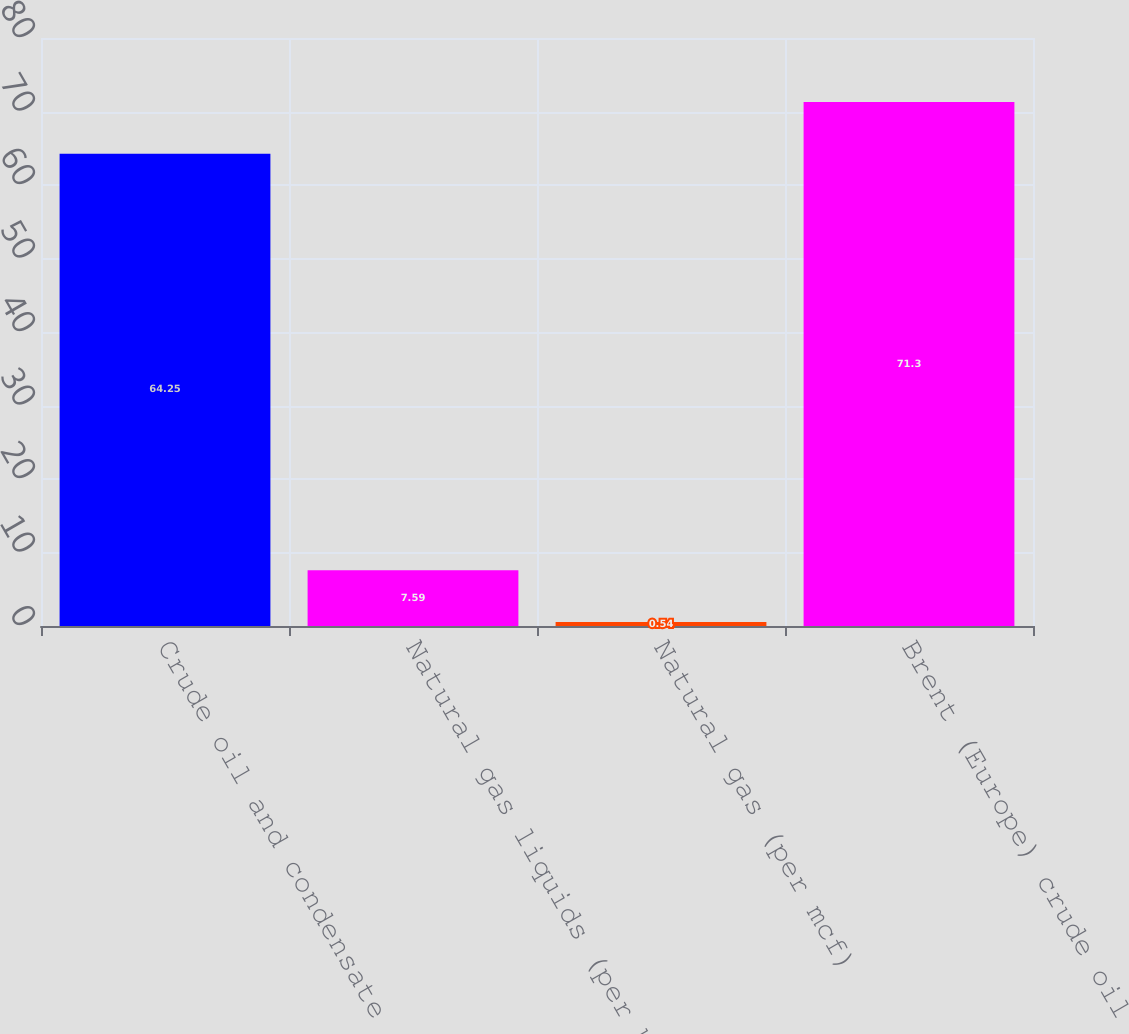<chart> <loc_0><loc_0><loc_500><loc_500><bar_chart><fcel>Crude oil and condensate (per<fcel>Natural gas liquids (per bbl)<fcel>Natural gas (per mcf)<fcel>Brent (Europe) crude oil (per<nl><fcel>64.25<fcel>7.59<fcel>0.54<fcel>71.3<nl></chart> 